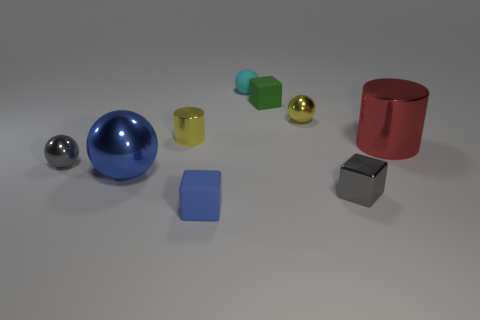There is a rubber thing in front of the tiny gray sphere; does it have the same color as the big thing on the left side of the tiny yellow shiny cylinder?
Your answer should be very brief. Yes. Is there another cyan matte object of the same shape as the tiny cyan object?
Provide a short and direct response. No. There is a green rubber object that is the same size as the yellow cylinder; what shape is it?
Make the answer very short. Cube. What is the material of the small yellow sphere?
Your response must be concise. Metal. There is a metallic cylinder on the right side of the metallic ball that is behind the small yellow thing that is in front of the tiny yellow sphere; what is its size?
Make the answer very short. Large. What material is the object that is the same color as the tiny cylinder?
Your answer should be very brief. Metal. What number of shiny objects are either blue blocks or green cubes?
Ensure brevity in your answer.  0. What is the size of the blue sphere?
Your response must be concise. Large. How many objects are blue cubes or small objects behind the small yellow metal cylinder?
Keep it short and to the point. 4. How many other things are the same color as the small shiny cylinder?
Give a very brief answer. 1. 